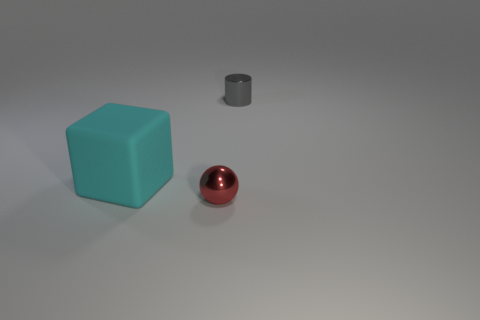Add 3 large balls. How many objects exist? 6 Subtract 1 cubes. How many cubes are left? 0 Add 3 tiny things. How many tiny things are left? 5 Add 3 balls. How many balls exist? 4 Subtract 0 yellow cubes. How many objects are left? 3 Subtract all balls. How many objects are left? 2 Subtract all purple cubes. Subtract all brown cylinders. How many cubes are left? 1 Subtract all blue cylinders. How many yellow cubes are left? 0 Subtract all big red metal things. Subtract all cylinders. How many objects are left? 2 